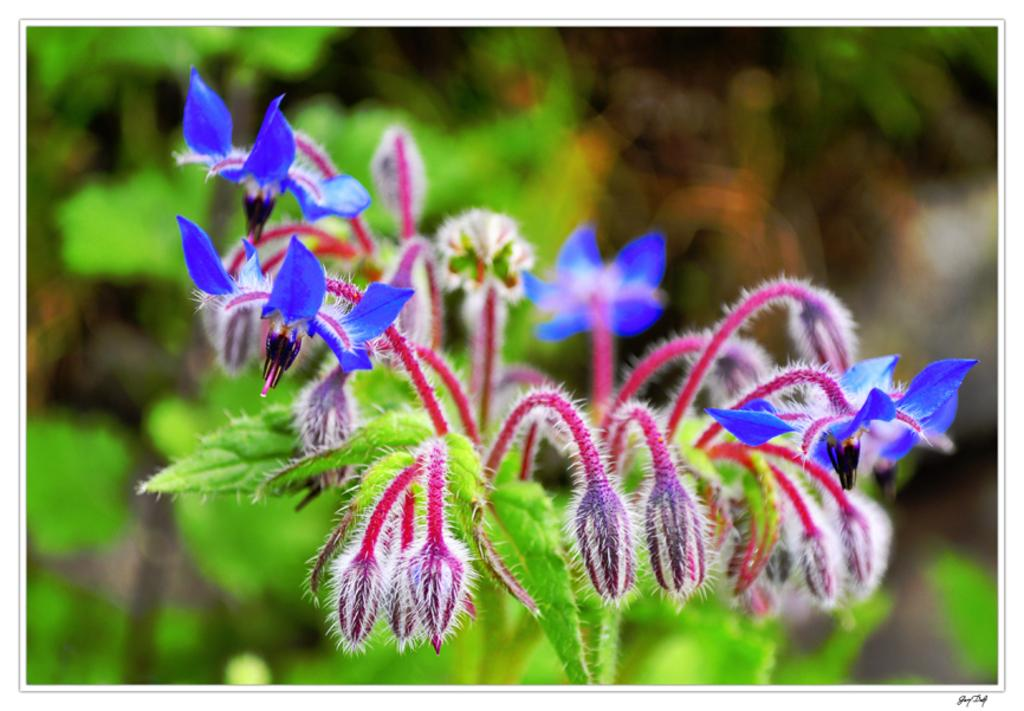What type of living organisms can be seen in the image? There are flowers and plants visible in the image. What else can be seen in the image besides the flowers and plants? There is text visible on the image. How would you describe the background of the image? The background of the image is blurred. Can you tell me how many farmers are visible in the image? There are no farmers present in the image; it features flowers, plants, and text. What type of stomach is visible in the image? There is no stomach present in the image. 